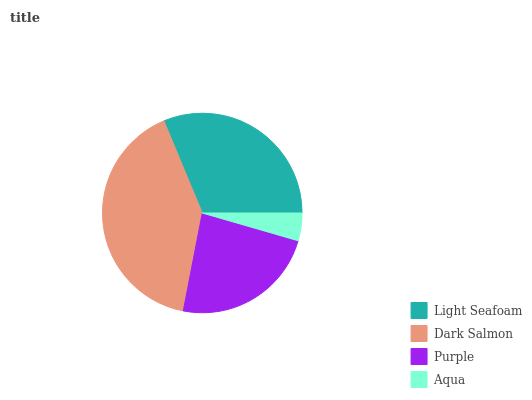Is Aqua the minimum?
Answer yes or no. Yes. Is Dark Salmon the maximum?
Answer yes or no. Yes. Is Purple the minimum?
Answer yes or no. No. Is Purple the maximum?
Answer yes or no. No. Is Dark Salmon greater than Purple?
Answer yes or no. Yes. Is Purple less than Dark Salmon?
Answer yes or no. Yes. Is Purple greater than Dark Salmon?
Answer yes or no. No. Is Dark Salmon less than Purple?
Answer yes or no. No. Is Light Seafoam the high median?
Answer yes or no. Yes. Is Purple the low median?
Answer yes or no. Yes. Is Dark Salmon the high median?
Answer yes or no. No. Is Aqua the low median?
Answer yes or no. No. 